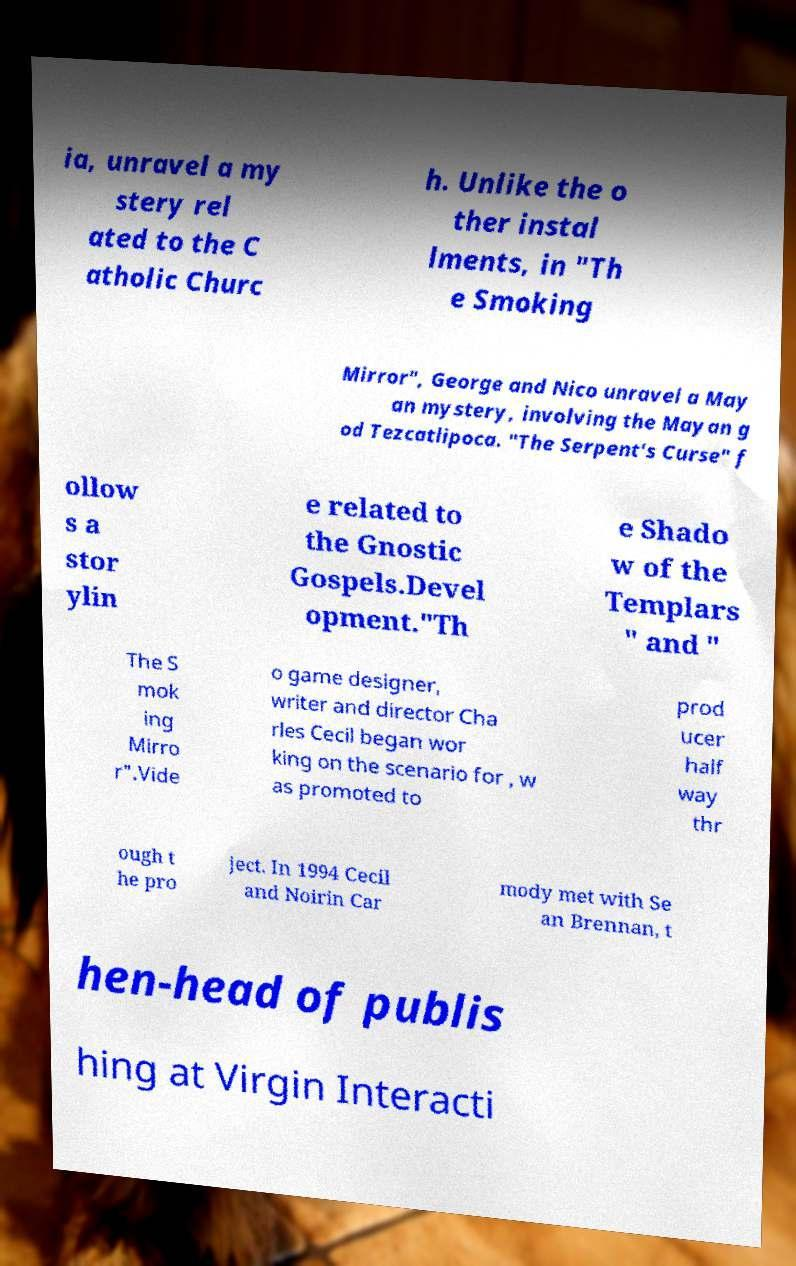Can you accurately transcribe the text from the provided image for me? ia, unravel a my stery rel ated to the C atholic Churc h. Unlike the o ther instal lments, in "Th e Smoking Mirror", George and Nico unravel a May an mystery, involving the Mayan g od Tezcatlipoca. "The Serpent's Curse" f ollow s a stor ylin e related to the Gnostic Gospels.Devel opment."Th e Shado w of the Templars " and " The S mok ing Mirro r".Vide o game designer, writer and director Cha rles Cecil began wor king on the scenario for , w as promoted to prod ucer half way thr ough t he pro ject. In 1994 Cecil and Noirin Car mody met with Se an Brennan, t hen-head of publis hing at Virgin Interacti 